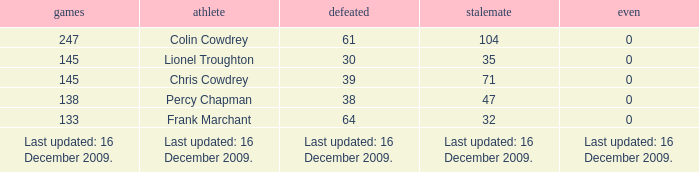Tell me the lost with tie of 0 and drawn of 47 38.0. 